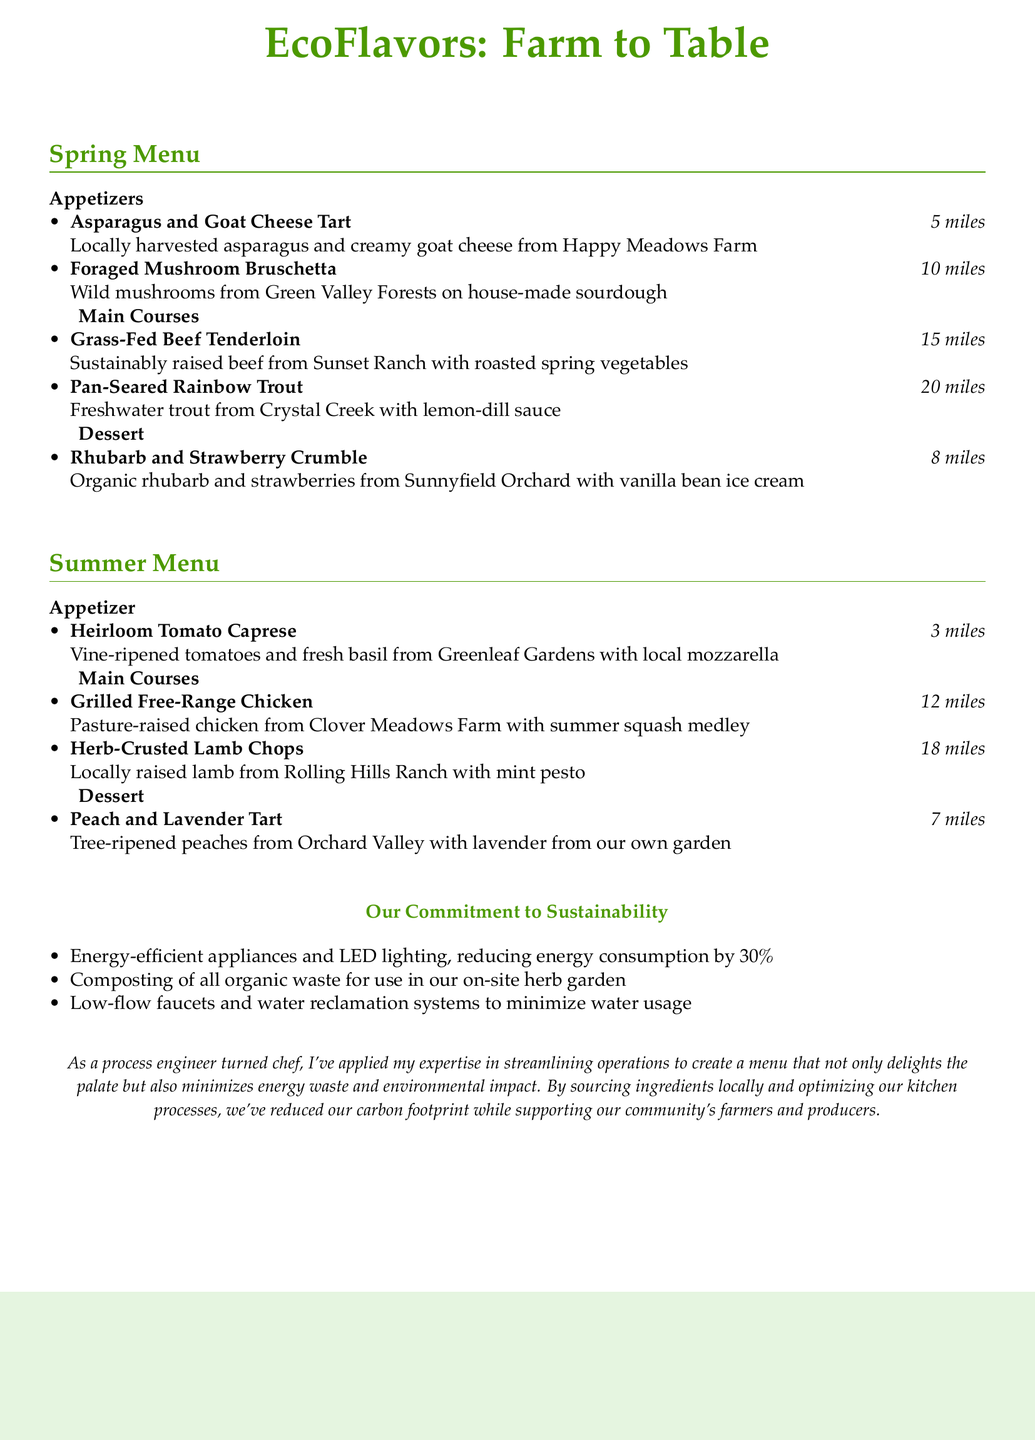What is the name of the dessert in the Spring Menu? The dessert listed in the Spring Menu is the Rhubarb and Strawberry Crumble.
Answer: Rhubarb and Strawberry Crumble How far are the ingredients for the Grass-Fed Beef Tenderloin sourced? The document states that the ingredients for this dish are sourced from 15 miles away.
Answer: 15 miles Which farm supplies the asparagus for the appetizer in the Spring Menu? The asparagus for the appetizer is sourced from Happy Meadows Farm.
Answer: Happy Meadows Farm What is the main ingredient in the Peach and Lavender Tart? The main ingredient mentioned in the description is tree-ripened peaches.
Answer: tree-ripened peaches Which season features the Grilled Free-Range Chicken? The document specifically includes the Grilled Free-Range Chicken in the Summer Menu.
Answer: Summer Menu What commitment is highlighted regarding energy efficiency? The document mentions the use of energy-efficient appliances and LED lighting.
Answer: energy-efficient appliances and LED lighting How many miles do the ingredients for the Heirloom Tomato Caprese travel? The ingredients for the Heirloom Tomato Caprese are sourced from 3 miles away.
Answer: 3 miles What are the two types of herbs mentioned that are used in the menu? The document mentions basil and lavender as the herbs incorporated in the dishes.
Answer: basil and lavender 